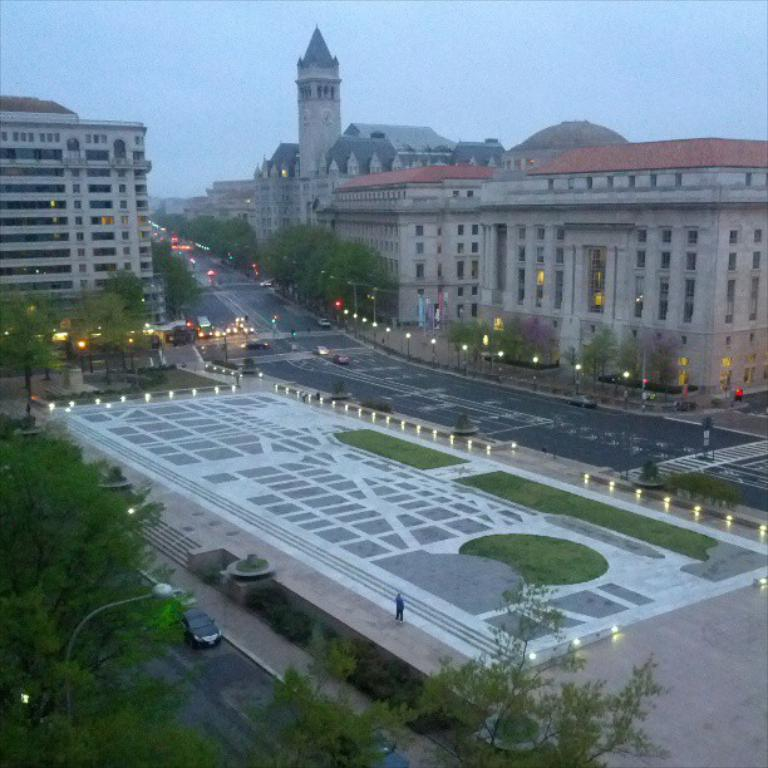What is the main feature of the image? There is a road in the image. What can be seen in the background of the image? There are buildings visible at the top of the image. What is visible in the sky in the image? The sky is visible in the image. What type of vegetation is on the left side of the image? There are trees visible on the left side of the image. What type of illumination is present in the middle of the image? There are lights visible in the middle of the image. What is the tendency of the dime to roll down the road in the image? There is no dime present in the image, so it is not possible to determine its tendency to roll down the road. 